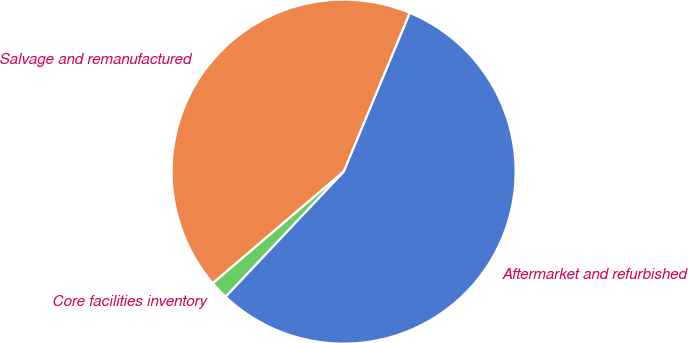<chart> <loc_0><loc_0><loc_500><loc_500><pie_chart><fcel>Aftermarket and refurbished<fcel>Salvage and remanufactured<fcel>Core facilities inventory<nl><fcel>55.76%<fcel>42.52%<fcel>1.71%<nl></chart> 